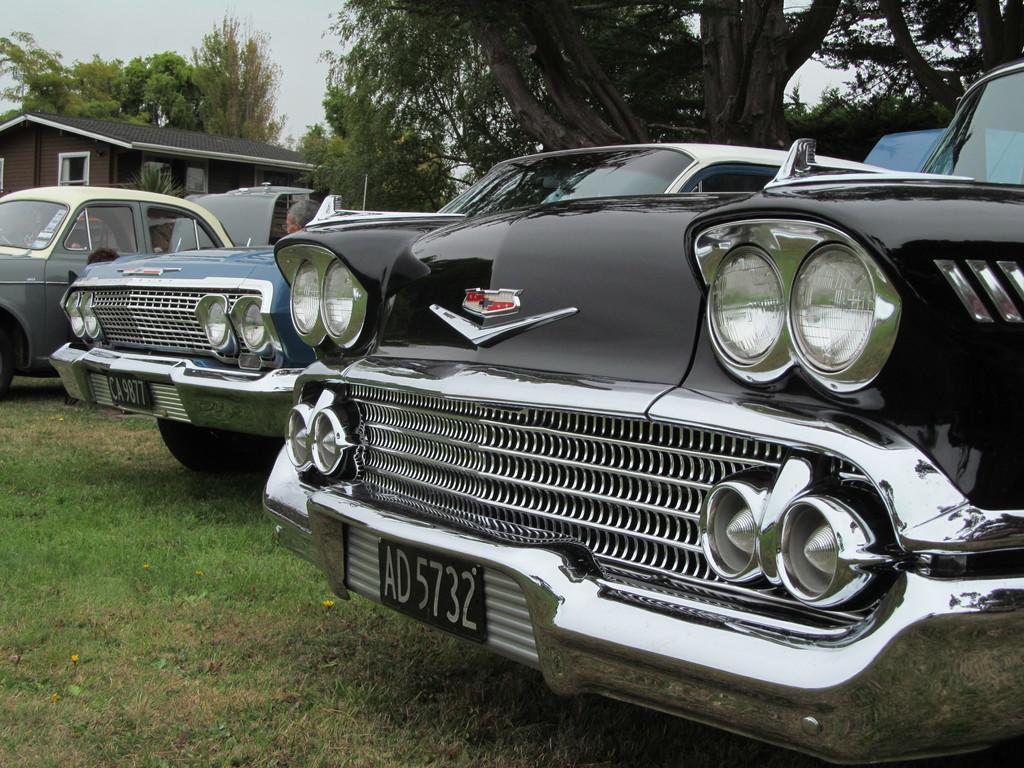Can you describe this image briefly? In this image few vehicles are on the grassland. Left side there is a house. Background there are few trees. Left top there is sky. 